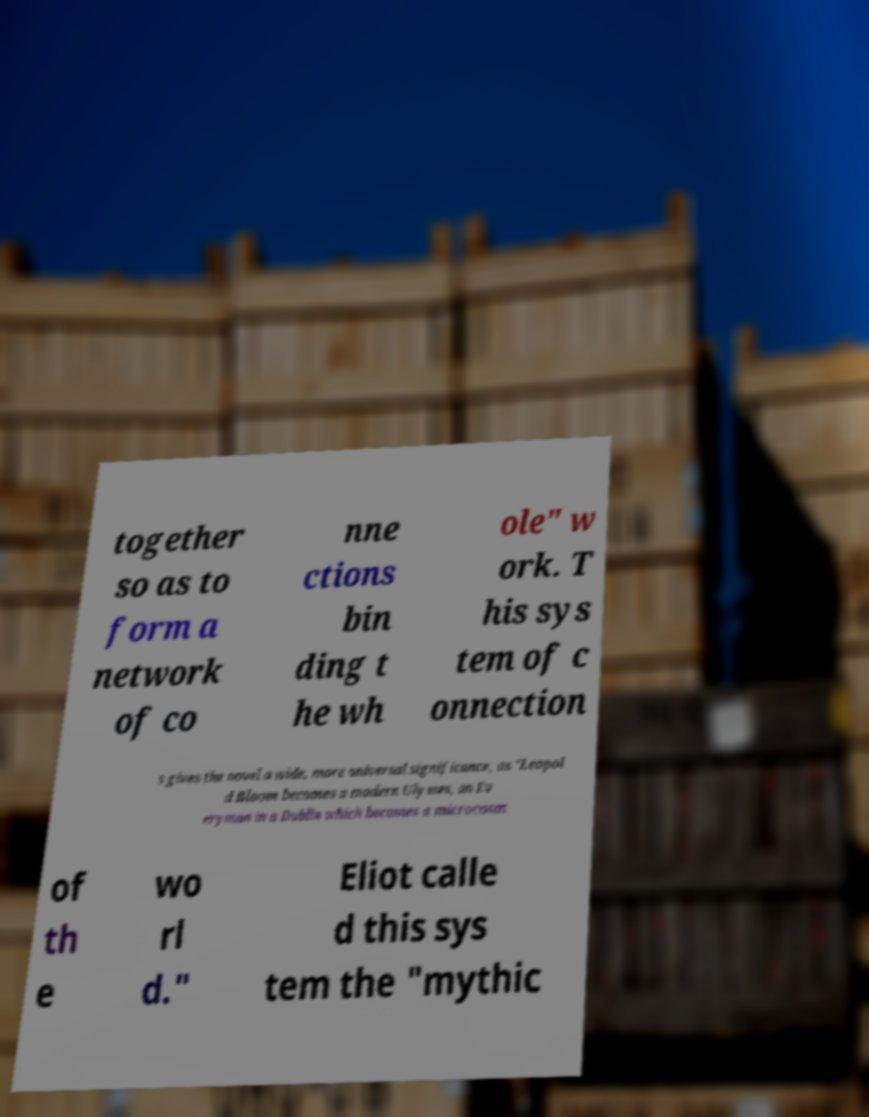For documentation purposes, I need the text within this image transcribed. Could you provide that? together so as to form a network of co nne ctions bin ding t he wh ole" w ork. T his sys tem of c onnection s gives the novel a wide, more universal significance, as "Leopol d Bloom becomes a modern Ulysses, an Ev eryman in a Dublin which becomes a microcosm of th e wo rl d." Eliot calle d this sys tem the "mythic 